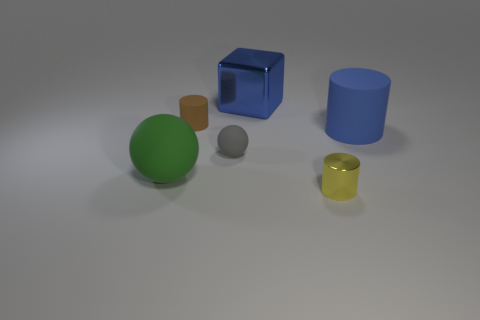Add 1 large blue blocks. How many objects exist? 7 Subtract all cubes. How many objects are left? 5 Subtract all brown things. Subtract all large green balls. How many objects are left? 4 Add 5 tiny yellow cylinders. How many tiny yellow cylinders are left? 6 Add 4 rubber things. How many rubber things exist? 8 Subtract 0 red cylinders. How many objects are left? 6 